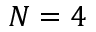Convert formula to latex. <formula><loc_0><loc_0><loc_500><loc_500>N = 4</formula> 